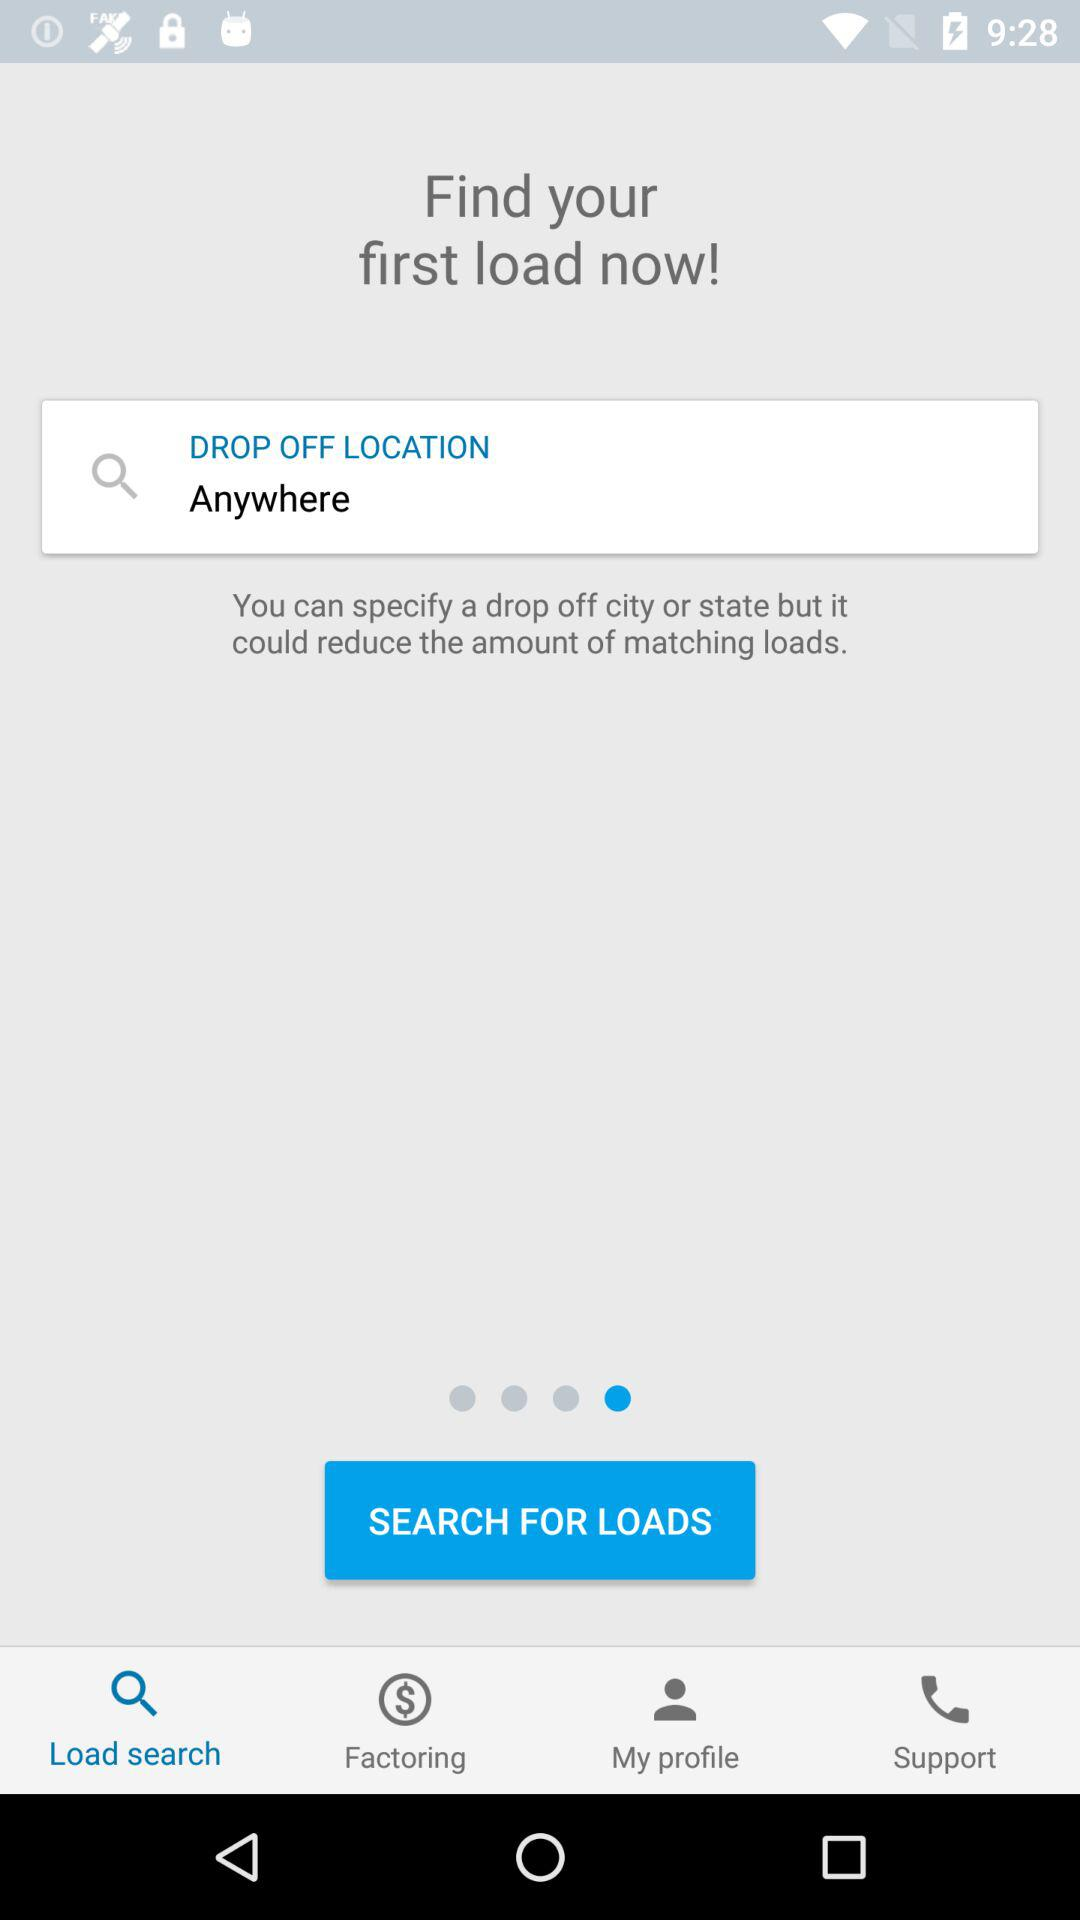What is the pick up location?
When the provided information is insufficient, respond with <no answer>. <no answer> 